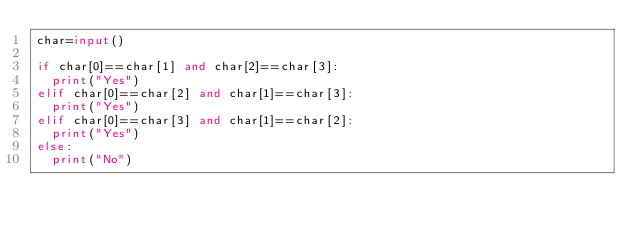<code> <loc_0><loc_0><loc_500><loc_500><_Python_>char=input()

if char[0]==char[1] and char[2]==char[3]:
	print("Yes")
elif char[0]==char[2] and char[1]==char[3]:
	print("Yes")
elif char[0]==char[3] and char[1]==char[2]:
	print("Yes")
else:
	print("No")</code> 